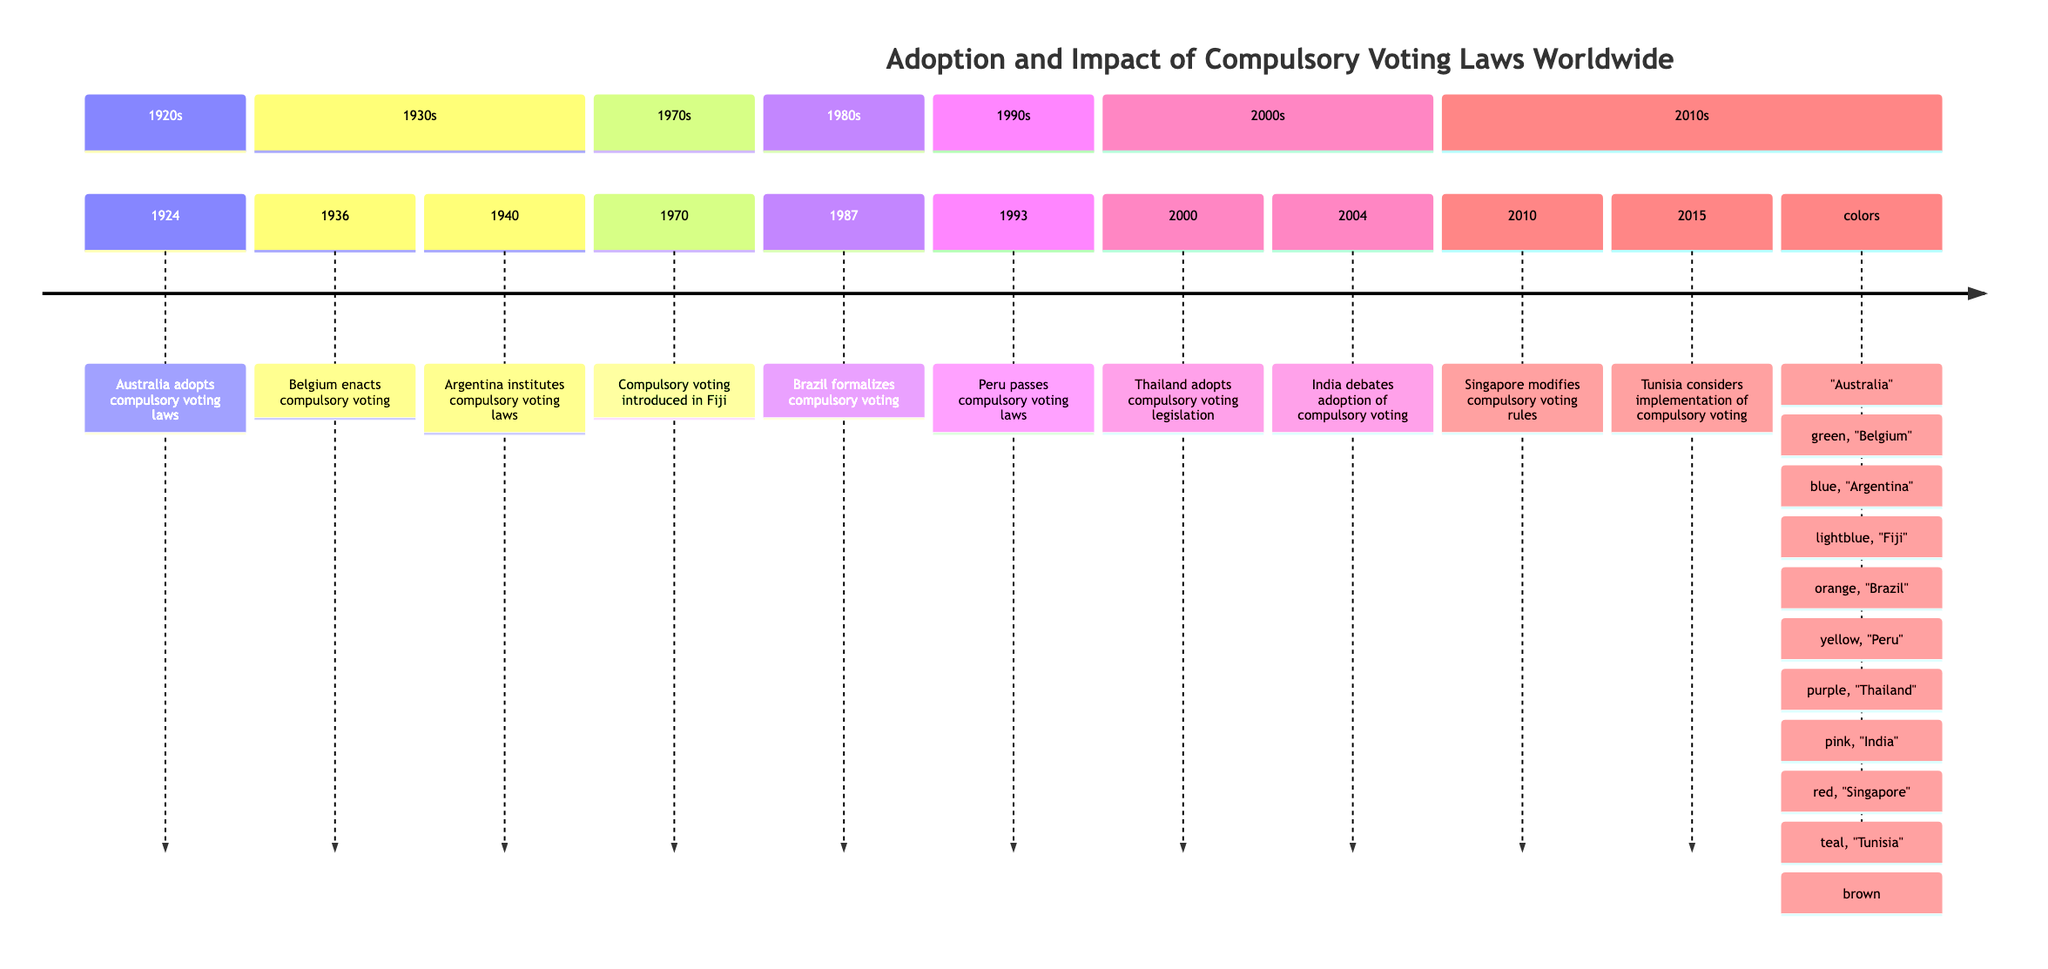What year did Australia adopt compulsory voting laws? According to the timeline, Australia adopted compulsory voting laws in the year 1924.
Answer: 1924 Which country enacted compulsory voting in 1936? The timeline indicates that Belgium enacted compulsory voting laws in the year 1936.
Answer: Belgium What event occurred in 1987? The timeline shows that in 1987, Brazil formalized compulsory voting for citizens aged 18 to 70.
Answer: Brazil formalizes compulsory voting Which two countries introduced compulsory voting laws in the 1940s? From the timeline, Argentina instituted compulsory voting laws in 1940, followed by Belgium which enacted it in 1936, but only Argentina falls within the 1940s. Therefore, only Argentina introduced compulsory voting laws during the 1940s.
Answer: Argentina What is the most recent year mentioned for a country considering compulsory voting? The timeline states that Tunisia considered the implementation of compulsory voting in the year 2015, which is the most recent year noted.
Answer: 2015 How many countries are listed in this timeline? By counting the unique entries in the timeline, there are a total of 10 countries listed that adopted or considered compulsory voting laws.
Answer: 10 Which country is associated with the year 2004 in the context of compulsory voting? The timeline indicates that the year 2004 is associated with India, which debated the adoption of compulsory voting laws.
Answer: India What was the goal of compulsory voting in Thailand in 2000? According to the timeline, the goal for introducing compulsory voting in Thailand in 2000 was to reduce political apathy and improve democratic participation.
Answer: Reduce political apathy and improve democratic participation Which two countries saw significant increases in voter turnout due to compulsory voting laws before 1970? The timeline shows that both Australia in 1924 and Belgium in 1936 saw significant increases in voter turnout as a result of their compulsory voting laws.
Answer: Australia and Belgium 